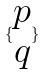Convert formula to latex. <formula><loc_0><loc_0><loc_500><loc_500>\{ \begin{matrix} p \\ q \end{matrix} \}</formula> 